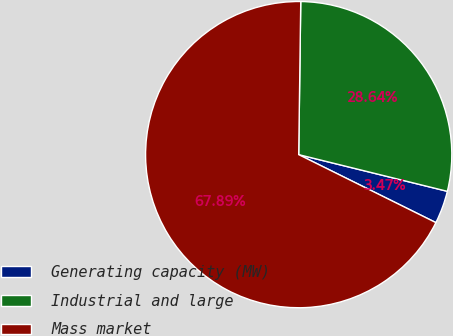Convert chart to OTSL. <chart><loc_0><loc_0><loc_500><loc_500><pie_chart><fcel>Generating capacity (MW)<fcel>Industrial and large<fcel>Mass market<nl><fcel>3.47%<fcel>28.64%<fcel>67.89%<nl></chart> 